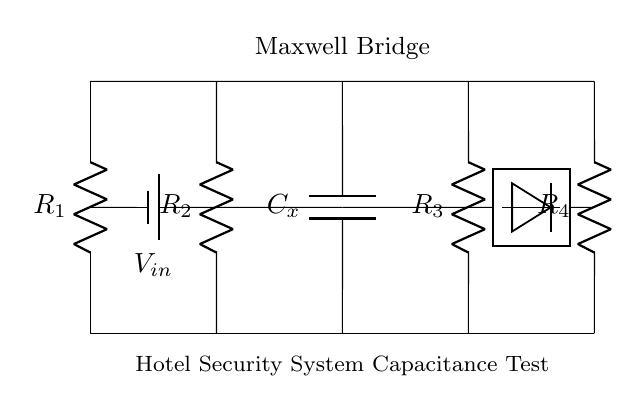What is the main function of this circuit? The main function is to measure capacitance by balancing the bridge, allowing for accurate readings when determining the value of the unknown capacitor in the hotel security system.
Answer: Measure capacitance What is the value of capacitor Cx? The value of capacitor Cx is determined based on the ratio of the resistances in the bridge. When balanced, the values can be calculated using the relationship involving known resistances and an unknown capacitance.
Answer: Unknown value How many resistors are present in the circuit? There are four resistors indicated in the circuit, identified as R1, R2, R3, and R4, which are essential for the operation of the Maxwell bridge.
Answer: Four What does the voltage source represent? The voltage source, labeled as V_in, represents the input voltage provided to the Maxwell Bridge circuit, necessary for generating the required measurements.
Answer: Input voltage What type of circuit is this? This is a Maxwell Bridge circuit, specifically designed for measuring capacitance within the context of hotel security systems.
Answer: Maxwell Bridge Which component is the unknown capacitance? The component labeled C_x represents the unknown capacitance that the circuit is designed to measure, essential for evaluating the performance of the security system.
Answer: C_x 